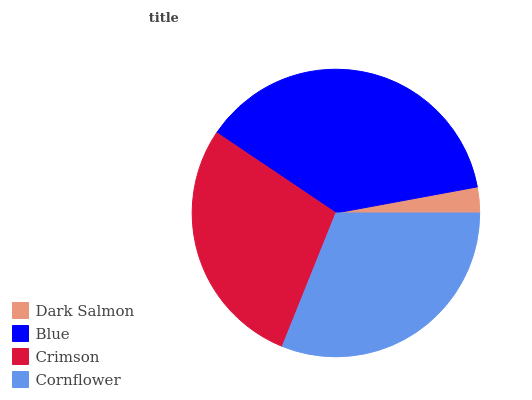Is Dark Salmon the minimum?
Answer yes or no. Yes. Is Blue the maximum?
Answer yes or no. Yes. Is Crimson the minimum?
Answer yes or no. No. Is Crimson the maximum?
Answer yes or no. No. Is Blue greater than Crimson?
Answer yes or no. Yes. Is Crimson less than Blue?
Answer yes or no. Yes. Is Crimson greater than Blue?
Answer yes or no. No. Is Blue less than Crimson?
Answer yes or no. No. Is Cornflower the high median?
Answer yes or no. Yes. Is Crimson the low median?
Answer yes or no. Yes. Is Crimson the high median?
Answer yes or no. No. Is Cornflower the low median?
Answer yes or no. No. 